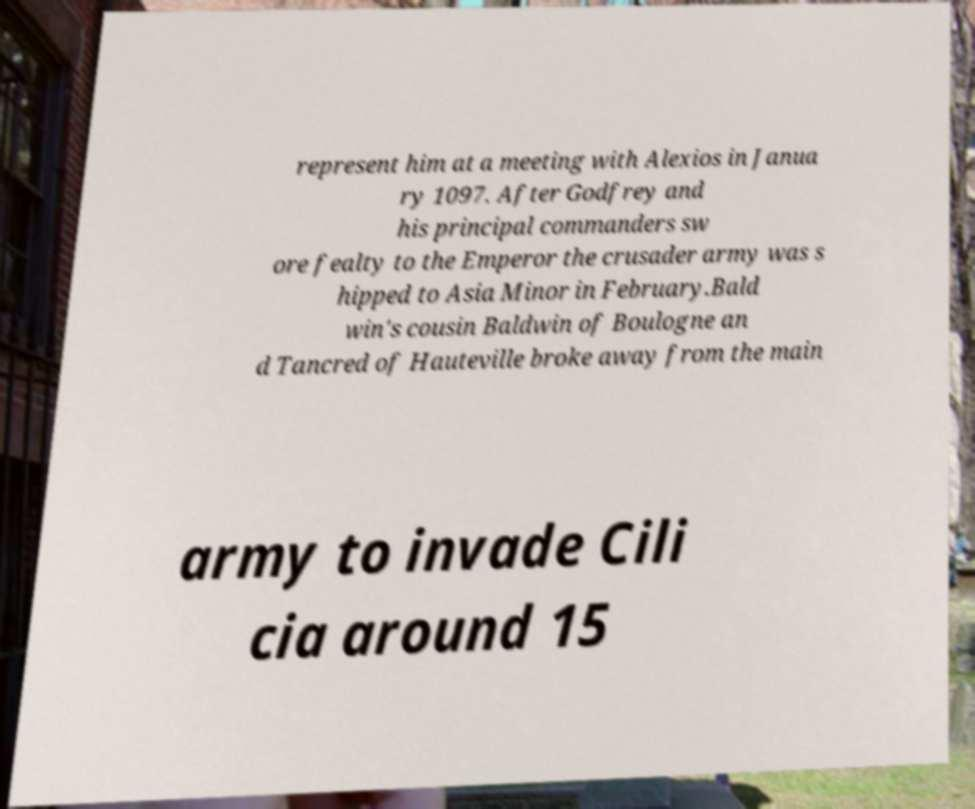Could you assist in decoding the text presented in this image and type it out clearly? represent him at a meeting with Alexios in Janua ry 1097. After Godfrey and his principal commanders sw ore fealty to the Emperor the crusader army was s hipped to Asia Minor in February.Bald win's cousin Baldwin of Boulogne an d Tancred of Hauteville broke away from the main army to invade Cili cia around 15 